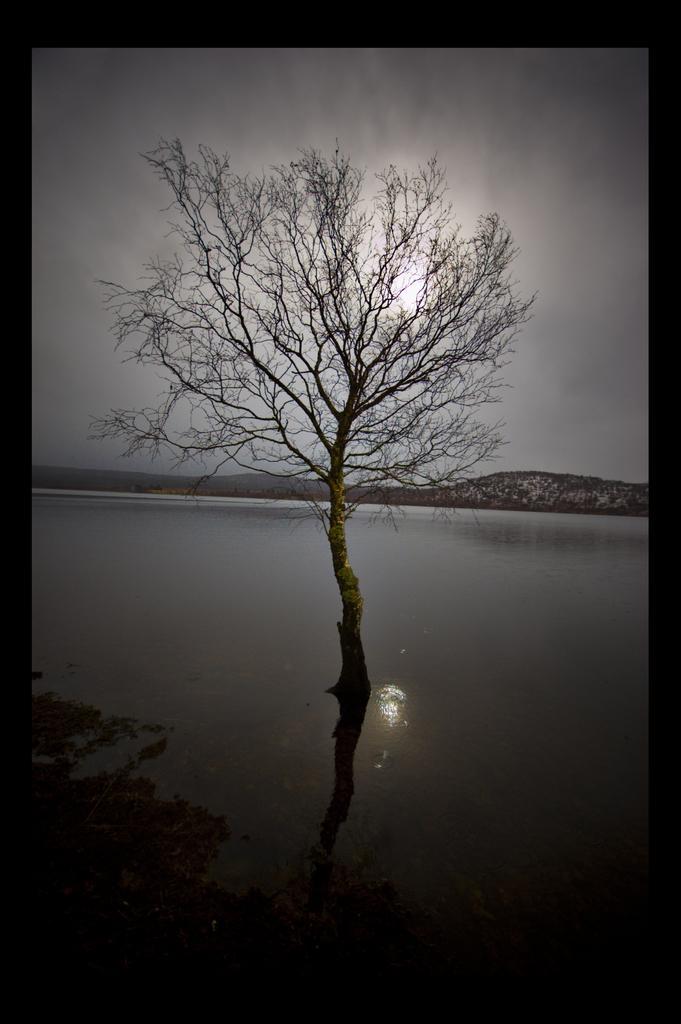In one or two sentences, can you explain what this image depicts? This is completely an outdoor picture which resembles the nature. On the background of the picture we can see a sky with a sun. These are the hills. this is a river. In Front of the picture we can see a bare tree which added a beauty to the whole picture. 